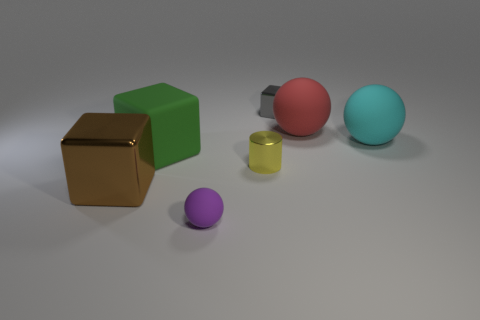Subtract all big matte balls. How many balls are left? 1 Subtract 1 blocks. How many blocks are left? 2 Add 3 tiny blue rubber cubes. How many objects exist? 10 Subtract all brown cubes. How many cubes are left? 2 Subtract all spheres. How many objects are left? 4 Add 1 red matte objects. How many red matte objects are left? 2 Add 3 shiny cubes. How many shiny cubes exist? 5 Subtract 0 purple cylinders. How many objects are left? 7 Subtract all red spheres. Subtract all purple cylinders. How many spheres are left? 2 Subtract all yellow shiny cylinders. Subtract all matte objects. How many objects are left? 2 